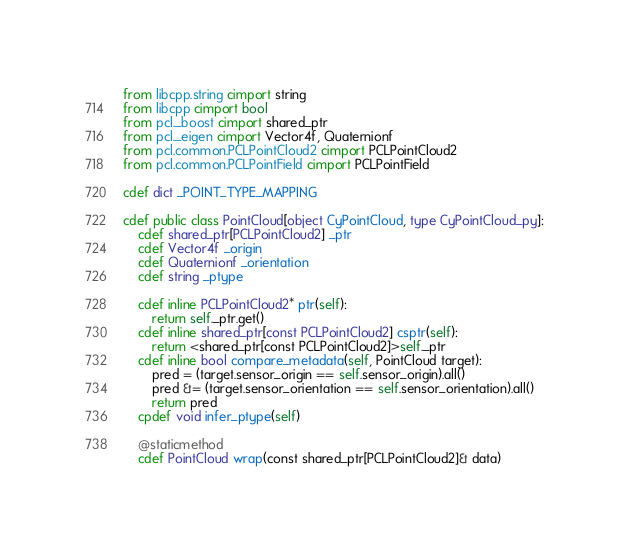<code> <loc_0><loc_0><loc_500><loc_500><_Cython_>from libcpp.string cimport string
from libcpp cimport bool
from pcl._boost cimport shared_ptr
from pcl._eigen cimport Vector4f, Quaternionf
from pcl.common.PCLPointCloud2 cimport PCLPointCloud2
from pcl.common.PCLPointField cimport PCLPointField

cdef dict _POINT_TYPE_MAPPING

cdef public class PointCloud[object CyPointCloud, type CyPointCloud_py]:
    cdef shared_ptr[PCLPointCloud2] _ptr
    cdef Vector4f _origin
    cdef Quaternionf _orientation
    cdef string _ptype
    
    cdef inline PCLPointCloud2* ptr(self):
        return self._ptr.get()
    cdef inline shared_ptr[const PCLPointCloud2] csptr(self):
        return <shared_ptr[const PCLPointCloud2]>self._ptr
    cdef inline bool compare_metadata(self, PointCloud target):
        pred = (target.sensor_origin == self.sensor_origin).all()
        pred &= (target.sensor_orientation == self.sensor_orientation).all()
        return pred
    cpdef void infer_ptype(self)

    @staticmethod
    cdef PointCloud wrap(const shared_ptr[PCLPointCloud2]& data)
</code> 